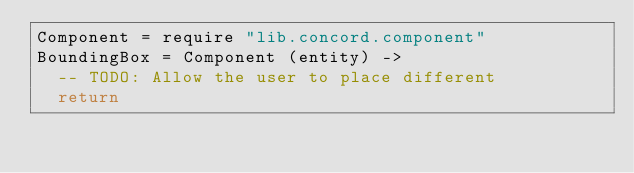<code> <loc_0><loc_0><loc_500><loc_500><_MoonScript_>Component = require "lib.concord.component"
BoundingBox = Component (entity) ->
	-- TODO: Allow the user to place different
	return </code> 